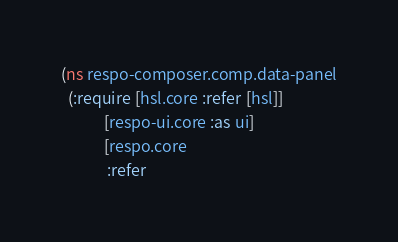<code> <loc_0><loc_0><loc_500><loc_500><_Clojure_>
(ns respo-composer.comp.data-panel
  (:require [hsl.core :refer [hsl]]
            [respo-ui.core :as ui]
            [respo.core
             :refer</code> 